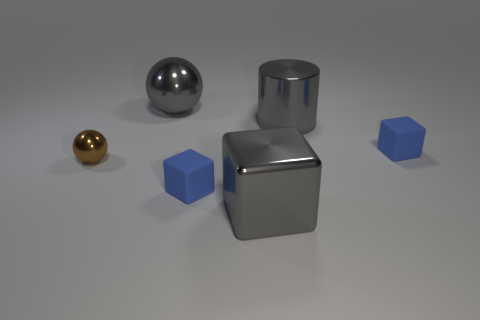Subtract all gray cubes. How many cubes are left? 2 Subtract all big metallic blocks. How many blocks are left? 2 Subtract 1 balls. How many balls are left? 1 Subtract all blue spheres. Subtract all blue cylinders. How many spheres are left? 2 Subtract all blue spheres. How many yellow blocks are left? 0 Subtract all big gray metal things. Subtract all brown spheres. How many objects are left? 2 Add 2 large objects. How many large objects are left? 5 Add 1 blue matte balls. How many blue matte balls exist? 1 Add 1 blue rubber objects. How many objects exist? 7 Subtract 0 yellow cubes. How many objects are left? 6 